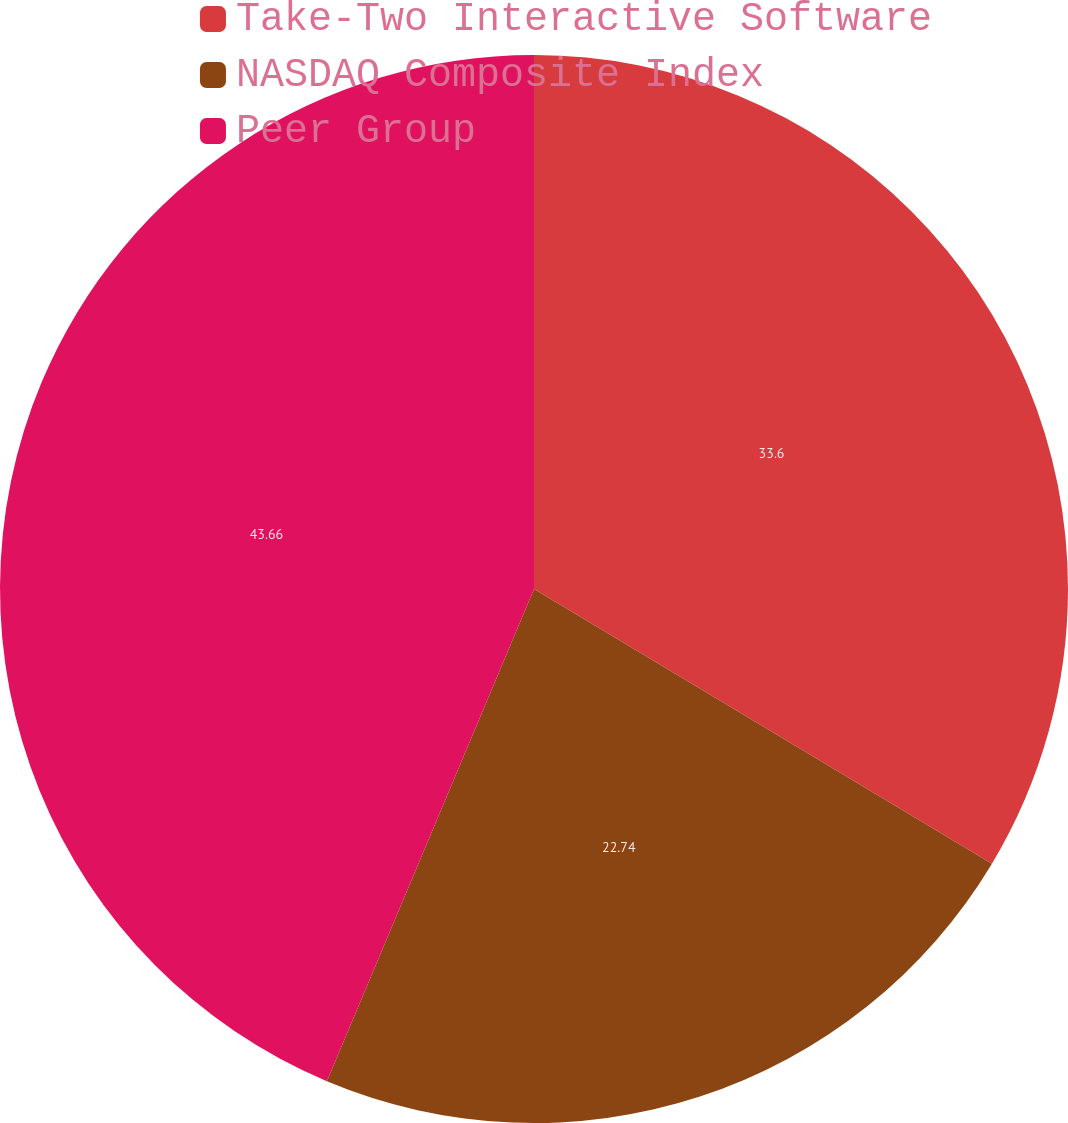Convert chart to OTSL. <chart><loc_0><loc_0><loc_500><loc_500><pie_chart><fcel>Take-Two Interactive Software<fcel>NASDAQ Composite Index<fcel>Peer Group<nl><fcel>33.6%<fcel>22.74%<fcel>43.66%<nl></chart> 